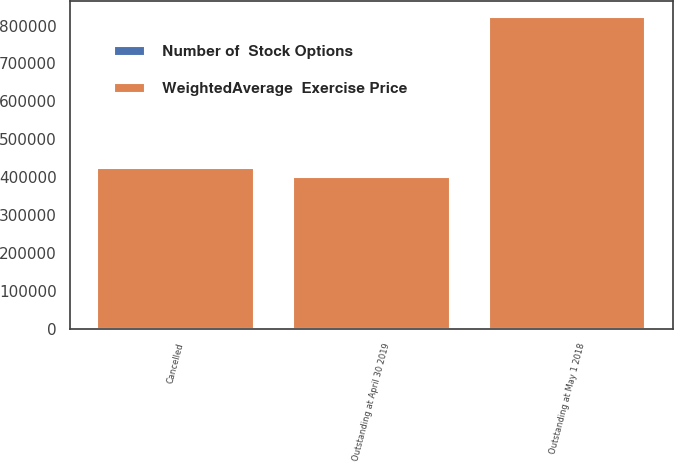Convert chart to OTSL. <chart><loc_0><loc_0><loc_500><loc_500><stacked_bar_chart><ecel><fcel>Outstanding at May 1 2018<fcel>Cancelled<fcel>Outstanding at April 30 2019<nl><fcel>WeightedAverage  Exercise Price<fcel>823332<fcel>423332<fcel>400000<nl><fcel>Number of  Stock Options<fcel>113.2<fcel>113.16<fcel>113.24<nl></chart> 